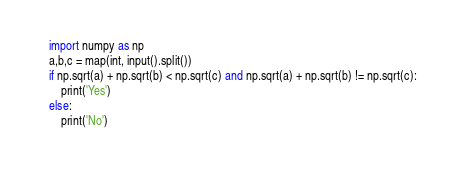Convert code to text. <code><loc_0><loc_0><loc_500><loc_500><_Python_>import numpy as np
a,b,c = map(int, input().split())
if np.sqrt(a) + np.sqrt(b) < np.sqrt(c) and np.sqrt(a) + np.sqrt(b) != np.sqrt(c):
    print('Yes')
else:
    print('No')</code> 